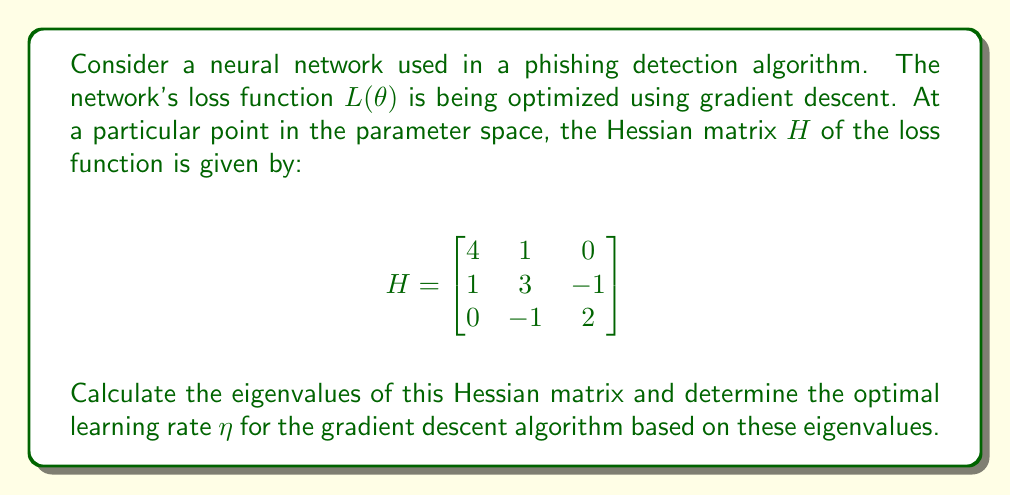Show me your answer to this math problem. To solve this problem, we'll follow these steps:

1) First, we need to find the eigenvalues of the Hessian matrix. The eigenvalues $\lambda$ are the solutions to the characteristic equation:

   $$det(H - \lambda I) = 0$$

   Where $I$ is the 3x3 identity matrix.

2) Expanding this determinant:

   $$\begin{vmatrix}
   4-\lambda & 1 & 0 \\
   1 & 3-\lambda & -1 \\
   0 & -1 & 2-\lambda
   \end{vmatrix} = 0$$

3) This gives us the characteristic polynomial:

   $$(4-\lambda)(3-\lambda)(2-\lambda) - (4-\lambda) - (2-\lambda) = 0$$

4) Simplifying:

   $$\lambda^3 - 9\lambda^2 + 24\lambda - 18 = 0$$

5) This cubic equation can be solved to find the eigenvalues. The solutions are:

   $$\lambda_1 = 2, \lambda_2 = 3, \lambda_3 = 4$$

6) In gradient descent, the optimal learning rate is typically chosen to be the reciprocal of the largest eigenvalue of the Hessian matrix. This ensures stable convergence.

7) The largest eigenvalue is $\lambda_3 = 4$.

8) Therefore, the optimal learning rate $\eta$ is:

   $$\eta = \frac{1}{\lambda_{max}} = \frac{1}{4}$$

This choice of learning rate ensures that the gradient descent algorithm converges smoothly without overshooting or diverging.
Answer: The eigenvalues of the Hessian matrix are $\lambda_1 = 2$, $\lambda_2 = 3$, and $\lambda_3 = 4$. The optimal learning rate for the gradient descent algorithm is $\eta = \frac{1}{4}$. 